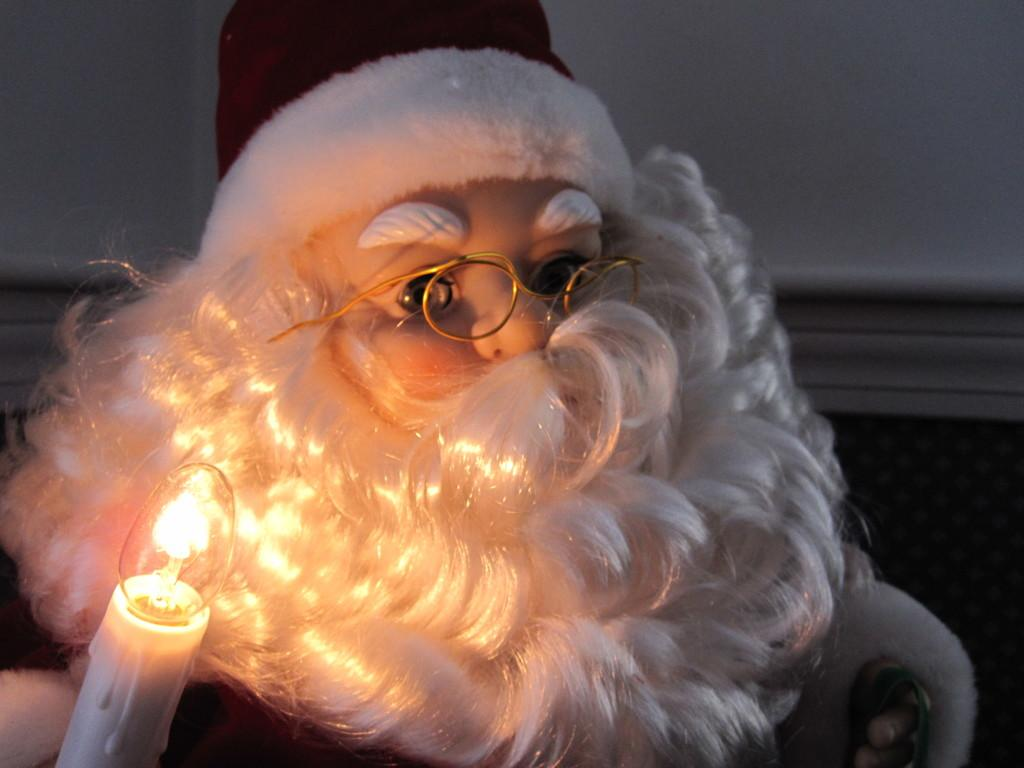What type of toy is present in the image? There is a toy Santa in the image. What is the toy Santa wearing? The toy Santa is wearing clothes, a cap, and spectacles. What other object can be seen in the image? There is a candle in the image. What is the background of the image? There is a wall in the image. What type of glass is the toy Santa holding in the image? There is no glass present in the image; the toy Santa is not holding anything. 